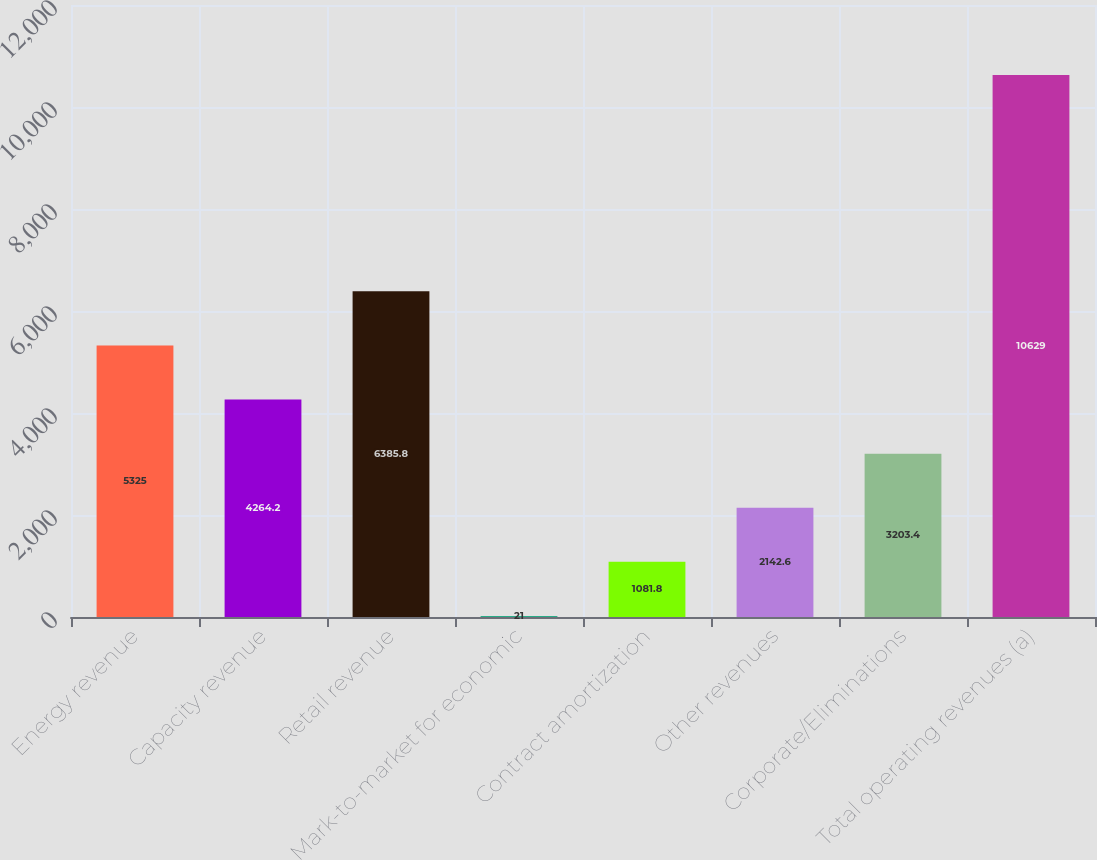Convert chart to OTSL. <chart><loc_0><loc_0><loc_500><loc_500><bar_chart><fcel>Energy revenue<fcel>Capacity revenue<fcel>Retail revenue<fcel>Mark-to-market for economic<fcel>Contract amortization<fcel>Other revenues<fcel>Corporate/Eliminations<fcel>Total operating revenues (a)<nl><fcel>5325<fcel>4264.2<fcel>6385.8<fcel>21<fcel>1081.8<fcel>2142.6<fcel>3203.4<fcel>10629<nl></chart> 